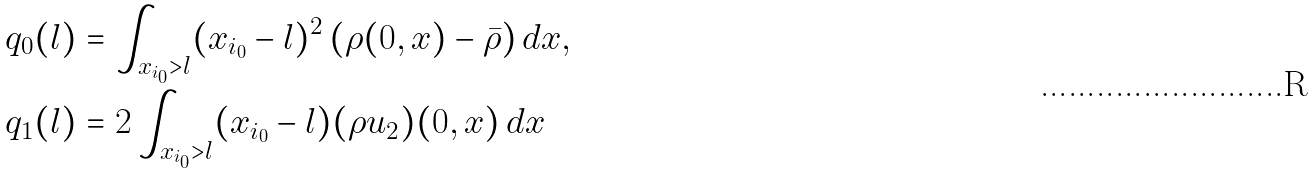<formula> <loc_0><loc_0><loc_500><loc_500>q _ { 0 } ( l ) & = \int _ { x _ { i _ { 0 } } > l } ( x _ { i _ { 0 } } - l ) ^ { 2 } \left ( \rho ( 0 , x ) - \bar { \rho } \right ) d x , \\ q _ { 1 } ( l ) & = 2 \int _ { x _ { i _ { 0 } } > l } ( x _ { i _ { 0 } } - l ) ( \rho u _ { 2 } ) ( 0 , x ) \, d x</formula> 